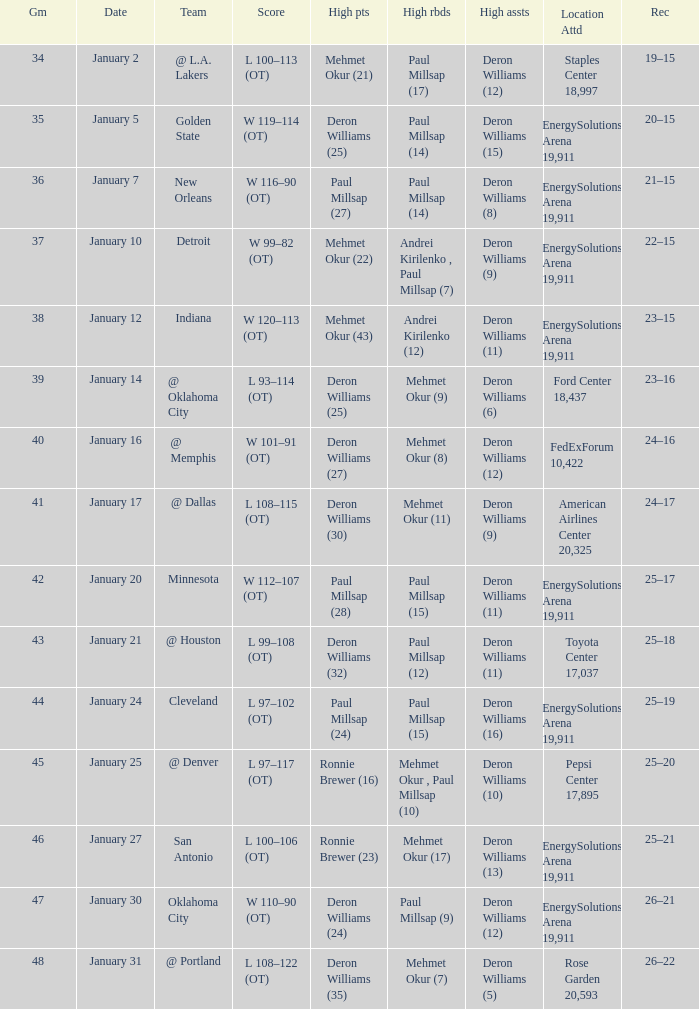Who had the high rebounds of the game that Deron Williams (5) had the high assists? Mehmet Okur (7). 